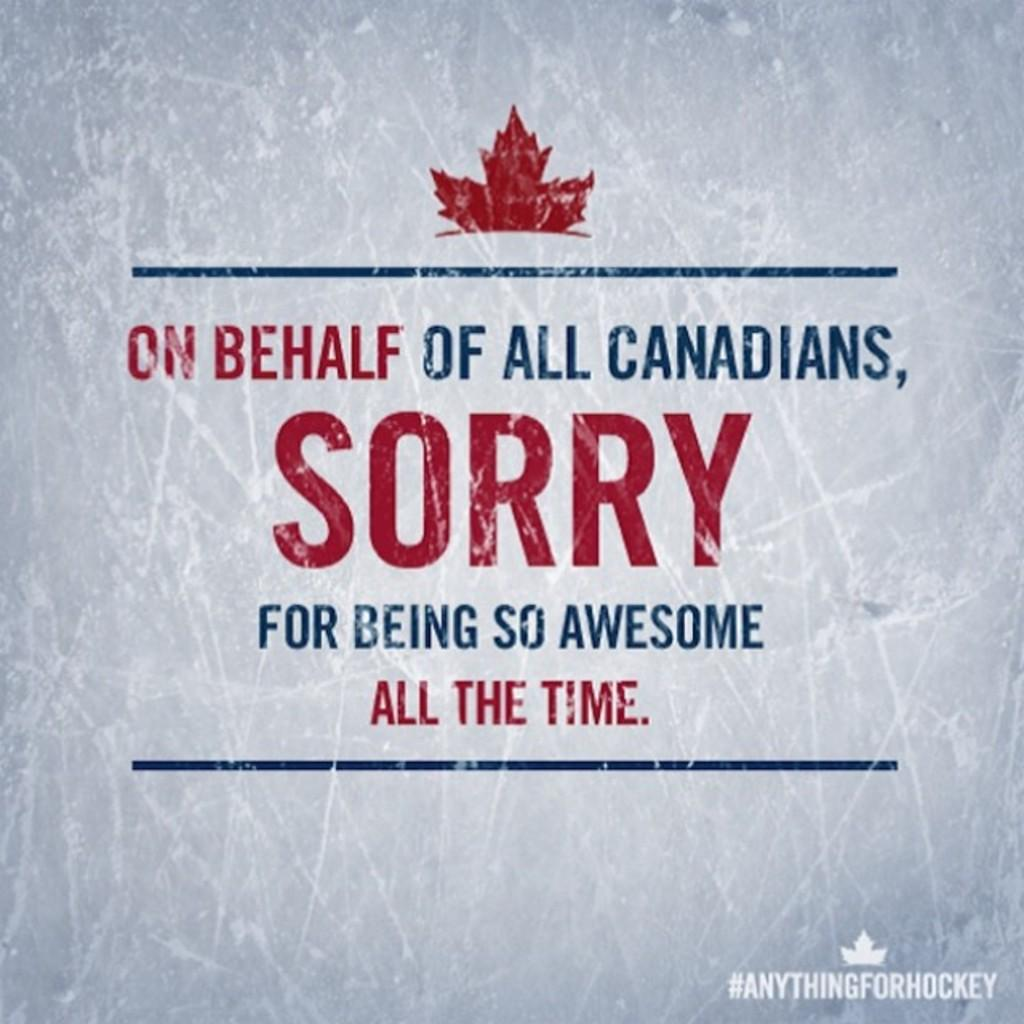What can be seen in the image related to advertising or information? There is a poster in the image. What is featured on the poster? There is text written on the poster. Reasoning: Let's think step by identifying the main subject in the image, which is the poster. Then, we expand the conversation to include the content of the poster, which is text. Each question is designed to elicit a specific detail about the image that is known from the provided facts. Absurd Question/Answer: What type of wax is being used to create a basket in the image? There is no basket or wax present in the image; it only features a poster with text. What type of drug is being advertised on the poster in the image? There is no drug mentioned or advertised on the poster in the image; it only features text. 